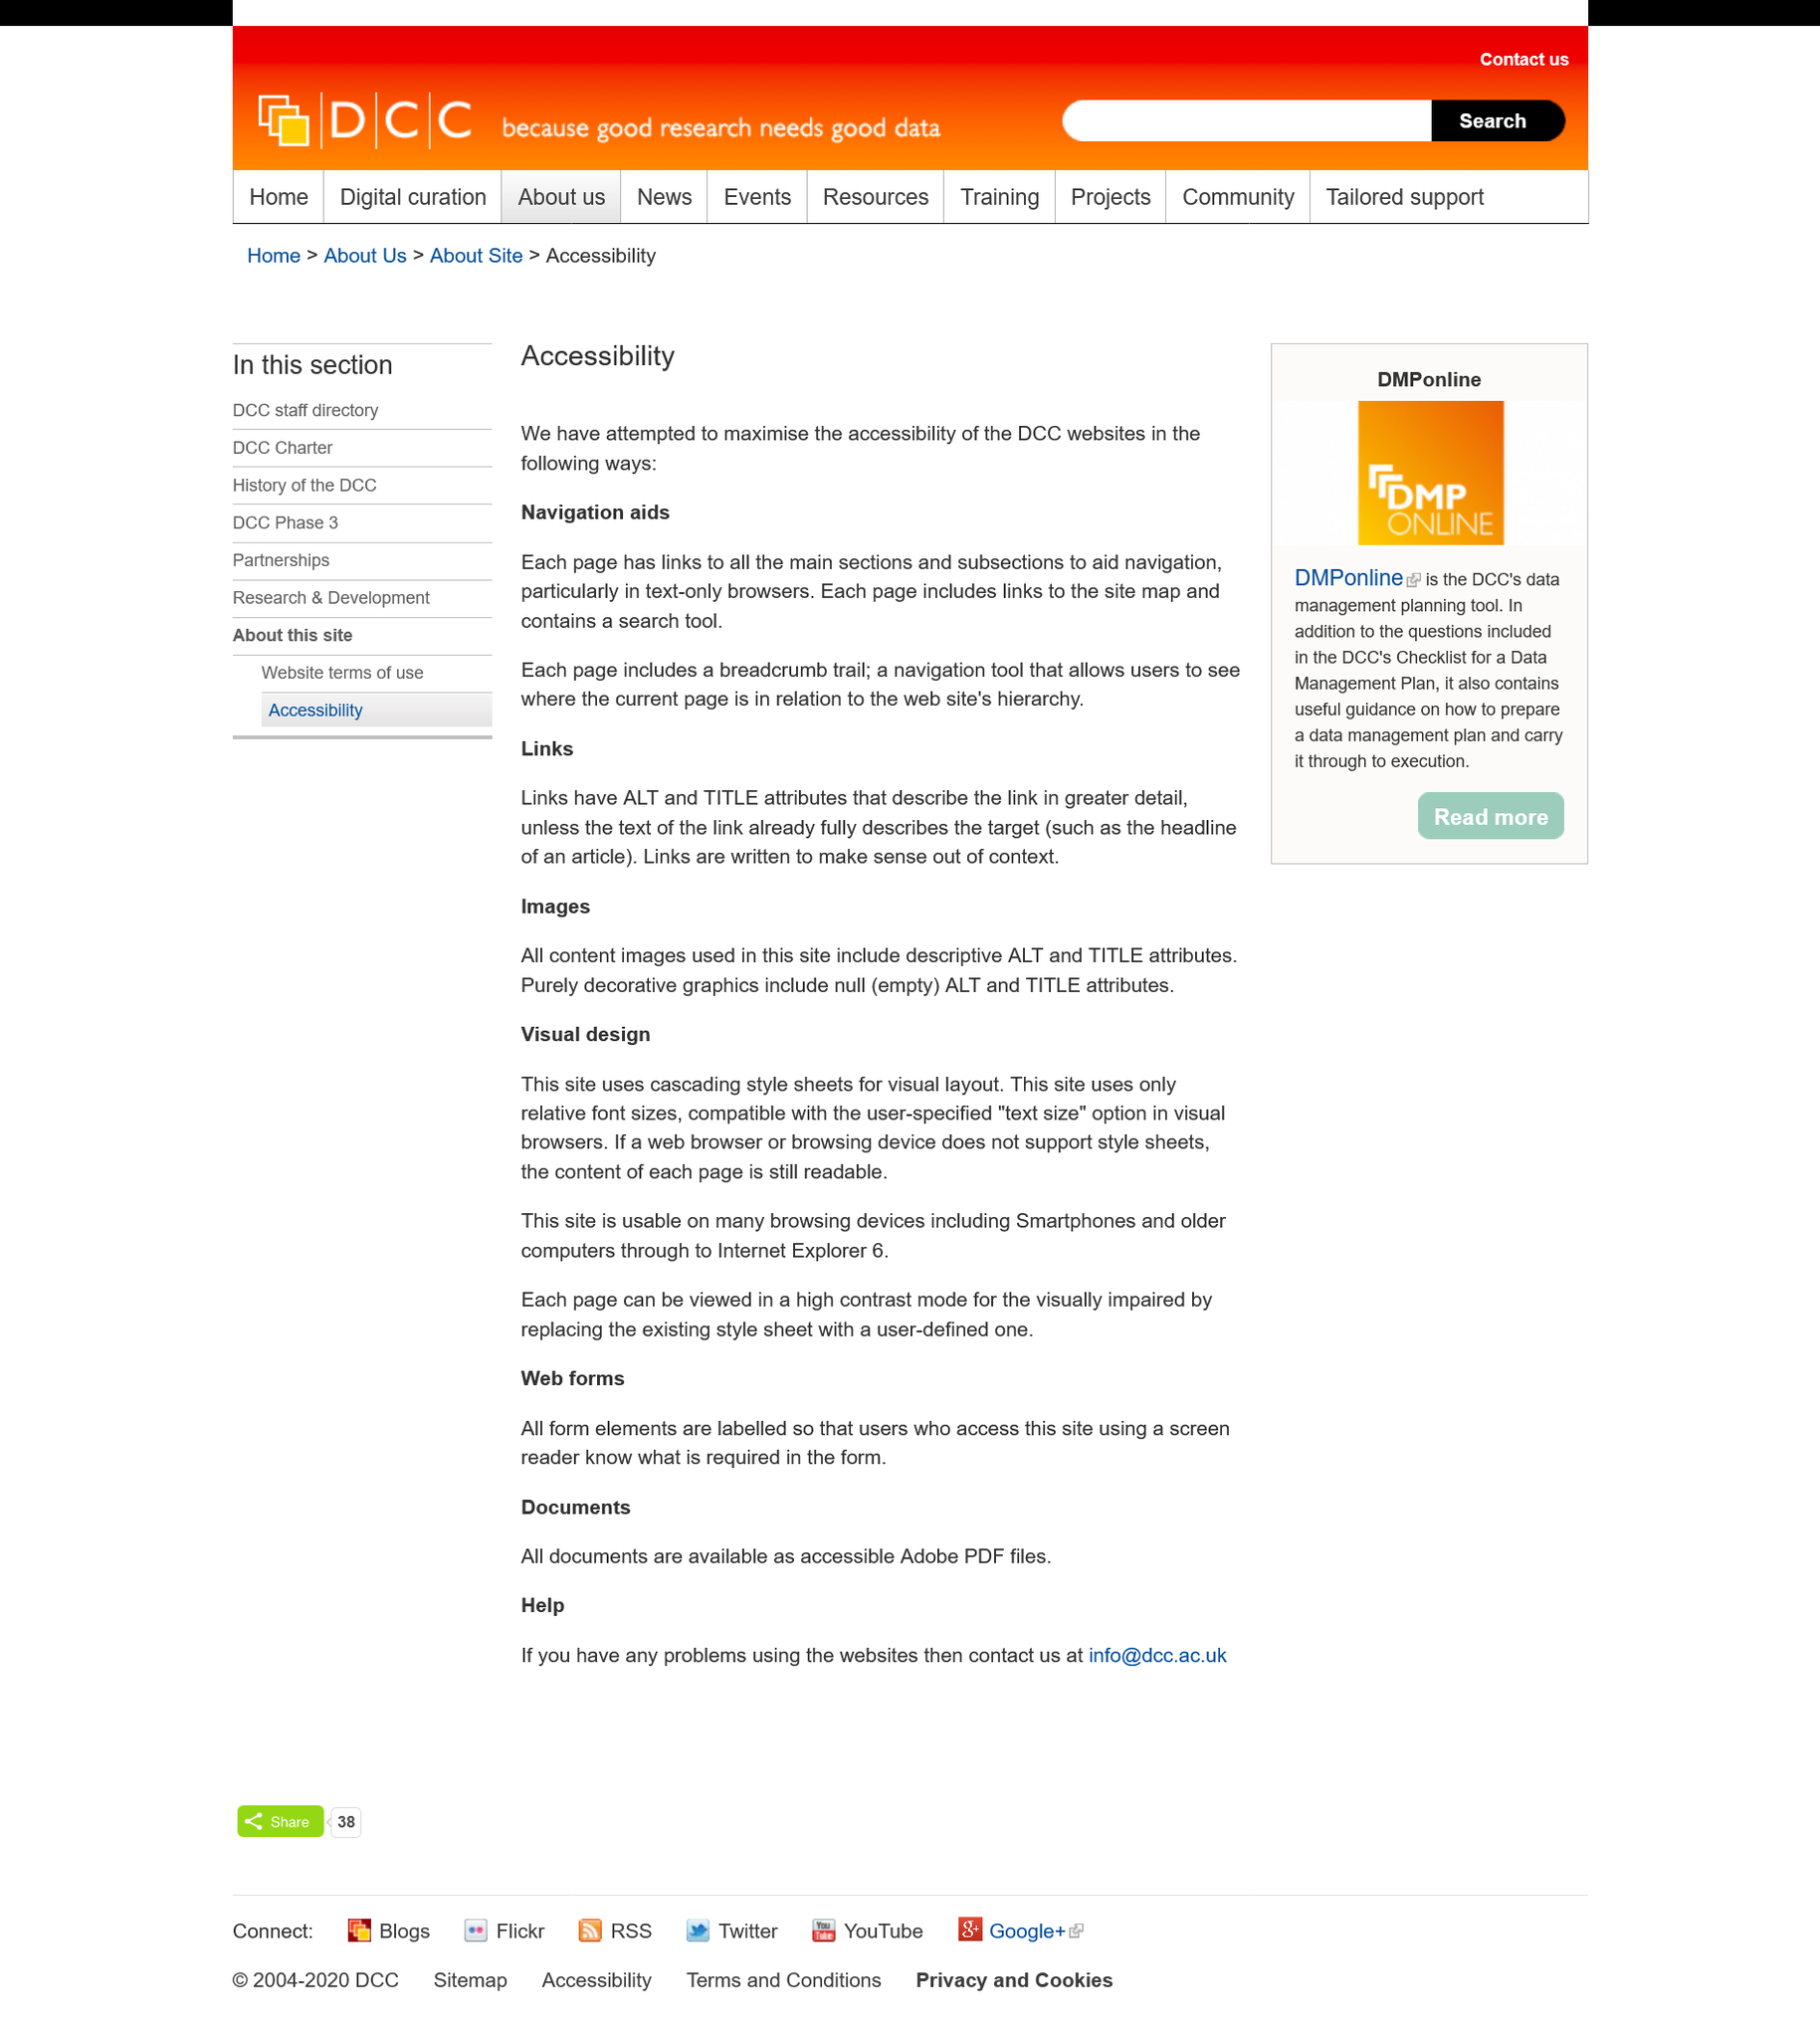Highlight a few significant elements in this photo. The visual layout of the site is determined by cascading style sheets. This website is compatible with various browsing devices, including smartphones, older computers, and Internet Explorer 6. A breadcrumb trail is included on each page. The use of navigation aids is one of the methods that the DCC websites have employed to enhance accessibility. The DCC websites have attempted to maximize accessibility by using links. 